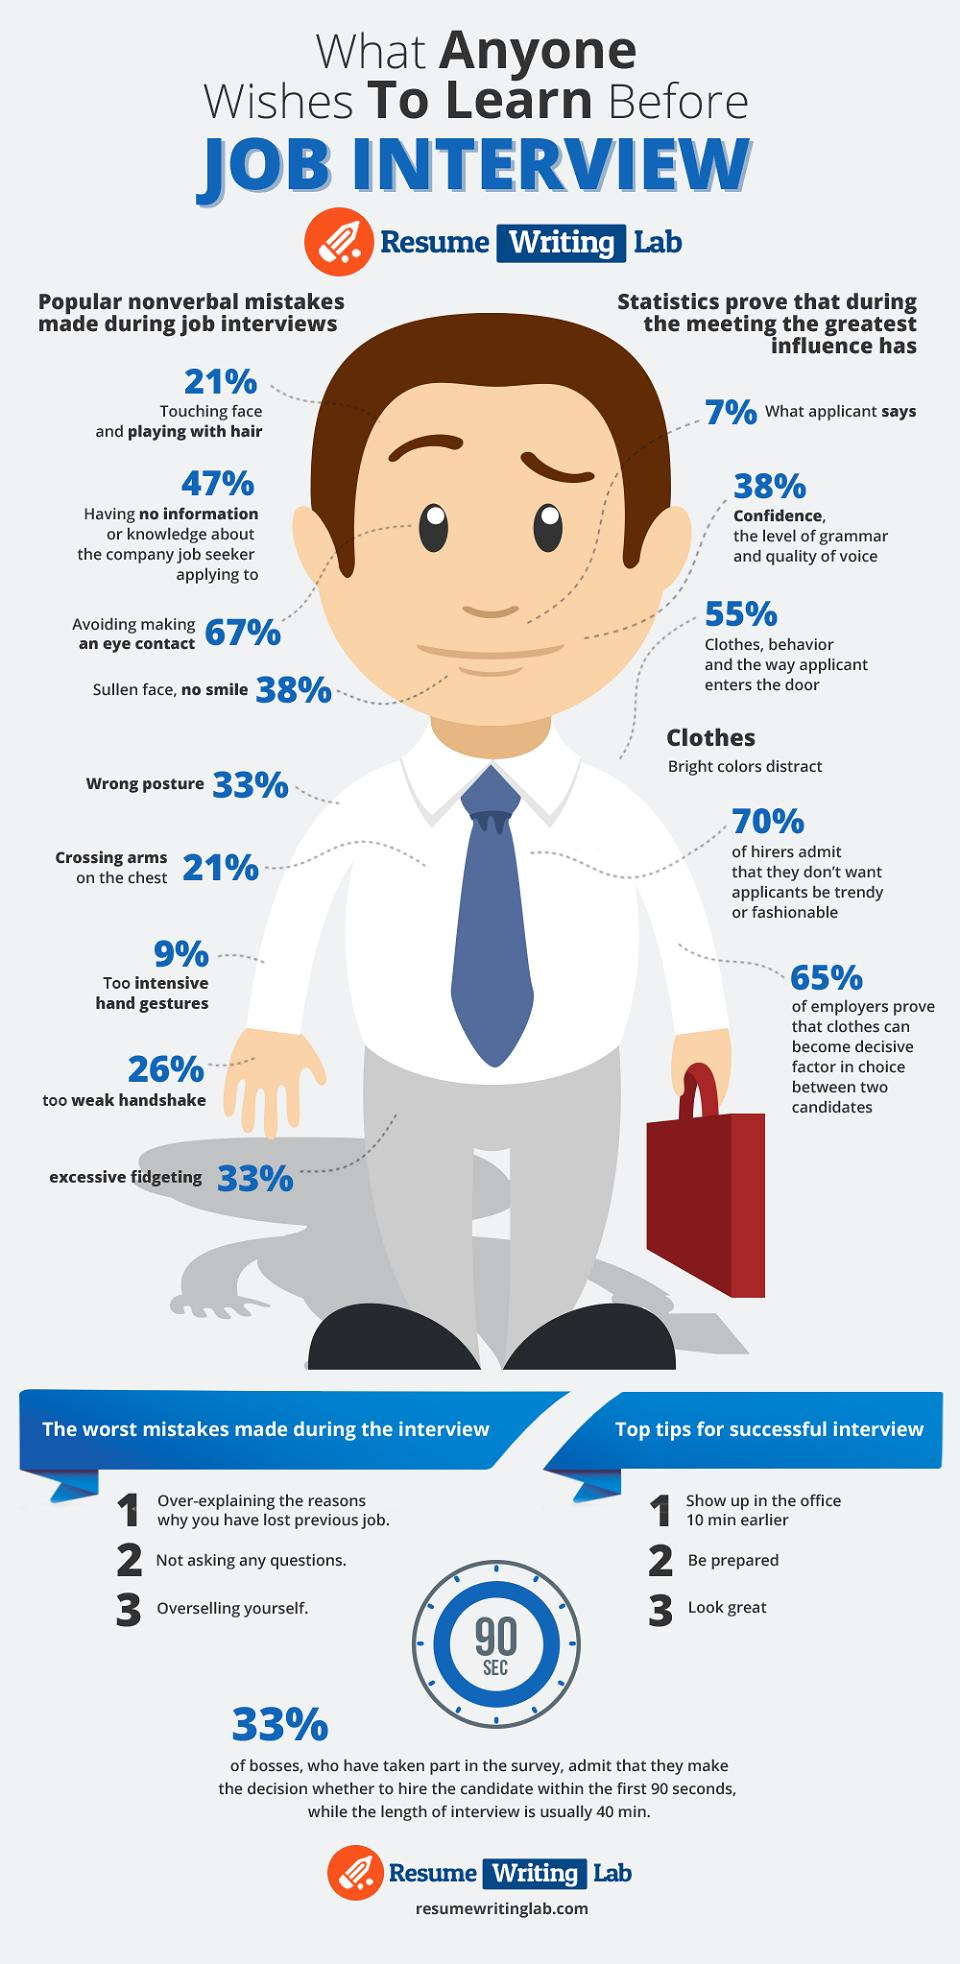Draw attention to some important aspects in this diagram. There are two points listed under the category of clothes, There are nine non-verbal mistakes listed. According to a survey, 21% of people engage in the behavior of playing with their hair or crossing their arms. Individuals who make the highest percentage of nonverbal mistakes, such as a weak handshake, improper posture, or lack of a smile, are most likely to have a negative impression left on those they interact with. 